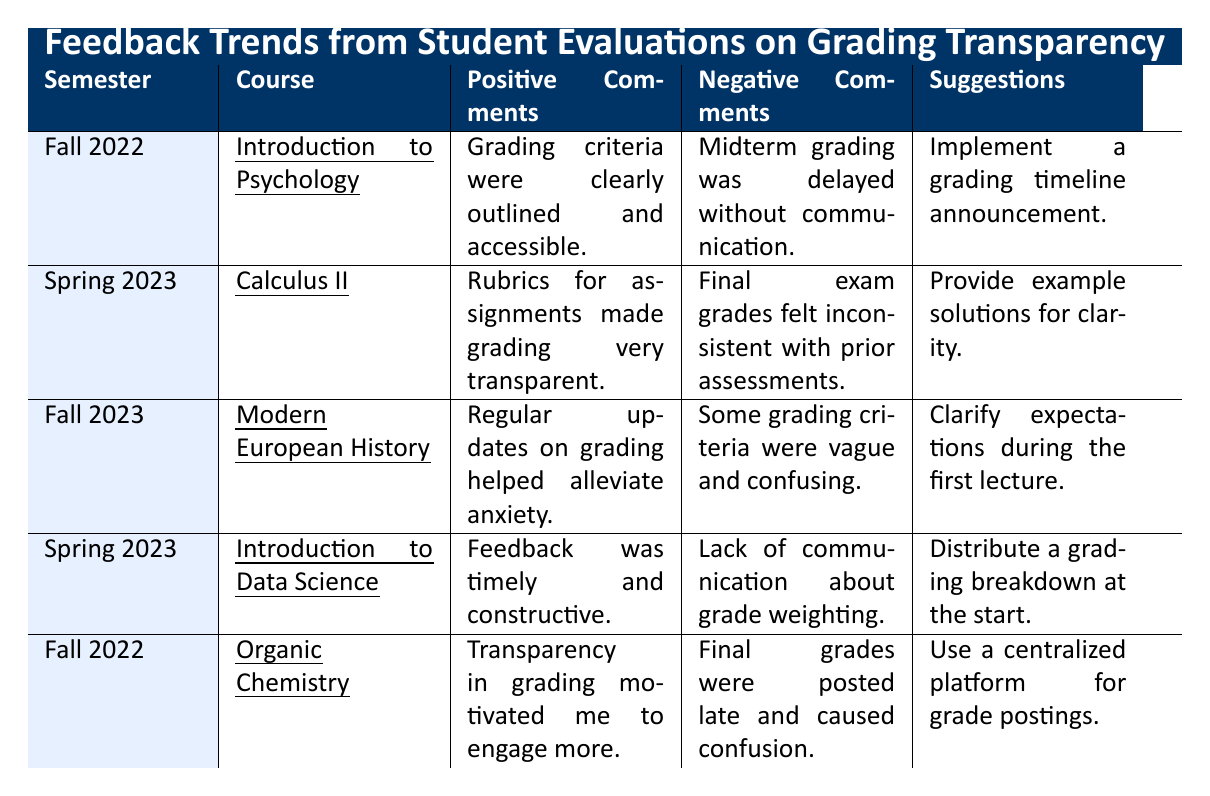What course did Dr. Alice Chen teach? According to the table, Dr. Alice Chen taught the course "Introduction to Data Science" in Spring 2023.
Answer: Introduction to Data Science Which instructor received positive comments about timely feedback? Dr. Alice Chen received positive comments regarding timely and constructive feedback for her course "Introduction to Data Science."
Answer: Dr. Alice Chen Did any course propose using a centralized platform for grade postings? Yes, the course "Organic Chemistry" taught by Dr. Michael Thompson suggested using a centralized platform for grade postings.
Answer: Yes How many courses received negative comments about grading delays? Two courses, "Introduction to Psychology" and "Organic Chemistry," received negative comments regarding delays in grading.
Answer: 2 What is the main suggestion for the course "Calculus II"? The suggestion for "Calculus II" is to provide example solutions for clarity, which was mentioned in the negative comments section.
Answer: Provide example solutions for clarity Which course had vague grading criteria as a negative comment? The course "Modern European History" taught by Dr. Robert Davis had vague and confusing grading criteria as a negative comment.
Answer: Modern European History What similarities can be found in the positive comments for "Introduction to Psychology" and "Organic Chemistry"? Both courses emphasized transparency in grading as a factor that motivated student engagement, suggesting that clear grading criteria or transparency enhances student motivation.
Answer: Both emphasized transparency in grading Are there recommendations to clarify grading expectations at the start of courses? Yes, both "Introduction to Data Science" and "Modern European History" suggest clarifying expectations during the first lecture or distributing a grading breakdown at the start.
Answer: Yes In which semester did students comment on the consistency of final exam grades? Students commented on the consistency of final exam grades in Spring 2023 for the course "Calculus II."
Answer: Spring 2023 Which course's feedback suggests improvements could be made in communication regarding grade weighting? The feedback for "Introduction to Data Science" suggested improvements in communication regarding grade weighting, indicating a lack of such communication.
Answer: Introduction to Data Science 